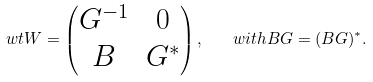<formula> <loc_0><loc_0><loc_500><loc_500>\ w t W = \begin{pmatrix} G ^ { - 1 } & 0 \\ B & G ^ { * } \end{pmatrix} , \quad w i t h B G = ( B G ) ^ { * } .</formula> 